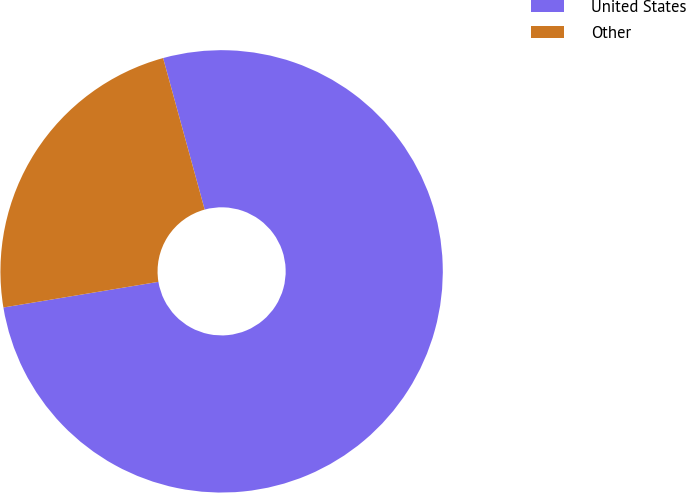<chart> <loc_0><loc_0><loc_500><loc_500><pie_chart><fcel>United States<fcel>Other<nl><fcel>76.65%<fcel>23.35%<nl></chart> 